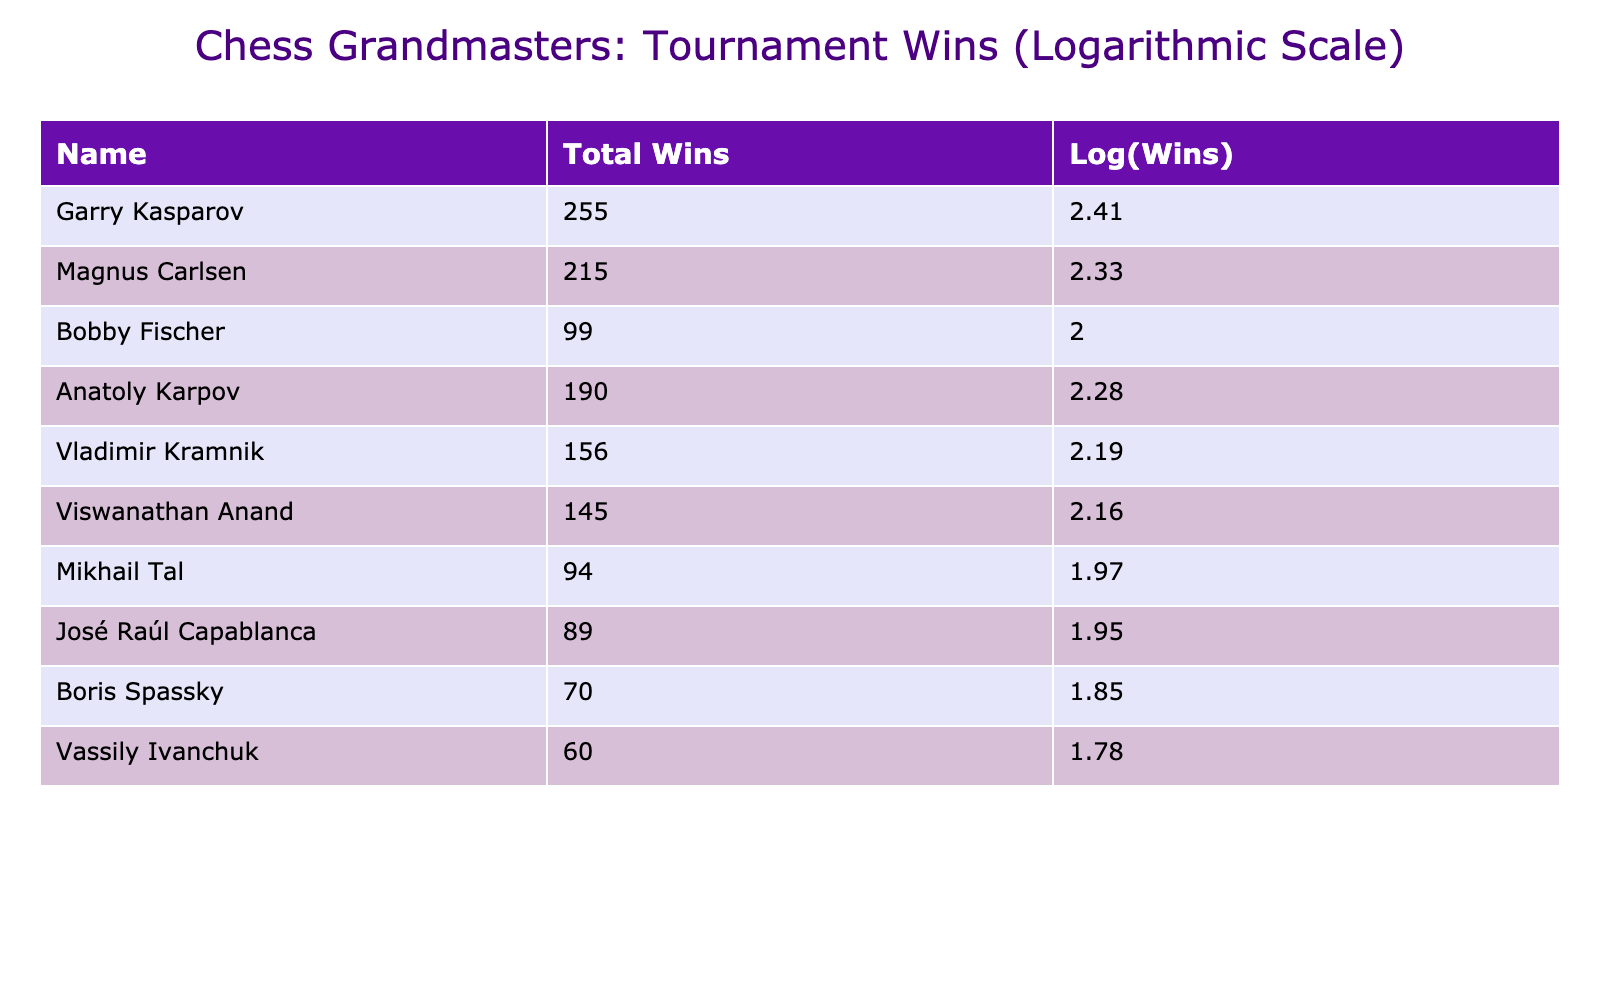What is the total number of tournament wins for Garry Kasparov? The table lists Garry Kasparov's total tournament wins, which is displayed directly as 255.
Answer: 255 Who has more total tournament wins, Magnus Carlsen or Anatoly Karpov? By checking the total tournament wins in the table, Magnus Carlsen has 215 wins while Anatoly Karpov has 190 wins. Since 215 is greater than 190, Magnus Carlsen has more.
Answer: Magnus Carlsen What is the logarithmic value of total tournament wins for Bobby Fischer? The table provides the total tournament wins for Bobby Fischer, which is 99. The logarithmic value is calculated as log10(99), resulting in approximately 1.996, which is rounded to 2.00 in the table.
Answer: 2.00 Is it true that José Raúl Capablanca has more total tournament wins than Mikhail Tal? The total tournament wins for José Raúl Capablanca is 89, and for Mikhail Tal, it is 94. Since 89 is less than 94, the statement is false.
Answer: No What is the difference in total tournament wins between Viswanathan Anand and Boris Spassky? Viswanathan Anand has 145 total tournament wins, and Boris Spassky has 70. To find the difference, subtract Spassky's wins from Anand's: 145 - 70 = 75.
Answer: 75 Which grandmaster has the least number of total tournament wins, and how many wins do they have? The table shows that Vassily Ivanchuk has 60 total tournament wins, which is the lowest among all listed grandmasters.
Answer: Vassily Ivanchuk, 60 What is the average total tournament wins of the top three grandmasters listed? The top three grandmasters (Garry Kasparov, Magnus Carlsen, and Anatoly Karpov) have a total of 255, 215, and 190 wins respectively. Adding them gives 255 + 215 + 190 = 660. Then, dividing by 3 gives an average of 660 / 3 = 220.
Answer: 220 What is the range of total tournament wins among the grandmasters listed? The highest total wins are 255 (Garry Kasparov) and the lowest are 60 (Vassily Ivanchuk). To find the range, subtract the lowest from the highest: 255 - 60 = 195.
Answer: 195 How many grandmasters have more than 100 total tournament wins? By examining the table, the grandmasters with more than 100 wins are Garry Kasparov, Magnus Carlsen, Anatoly Karpov, Vladimir Kramnik, and Viswanathan Anand. There are 5 such grandmasters.
Answer: 5 